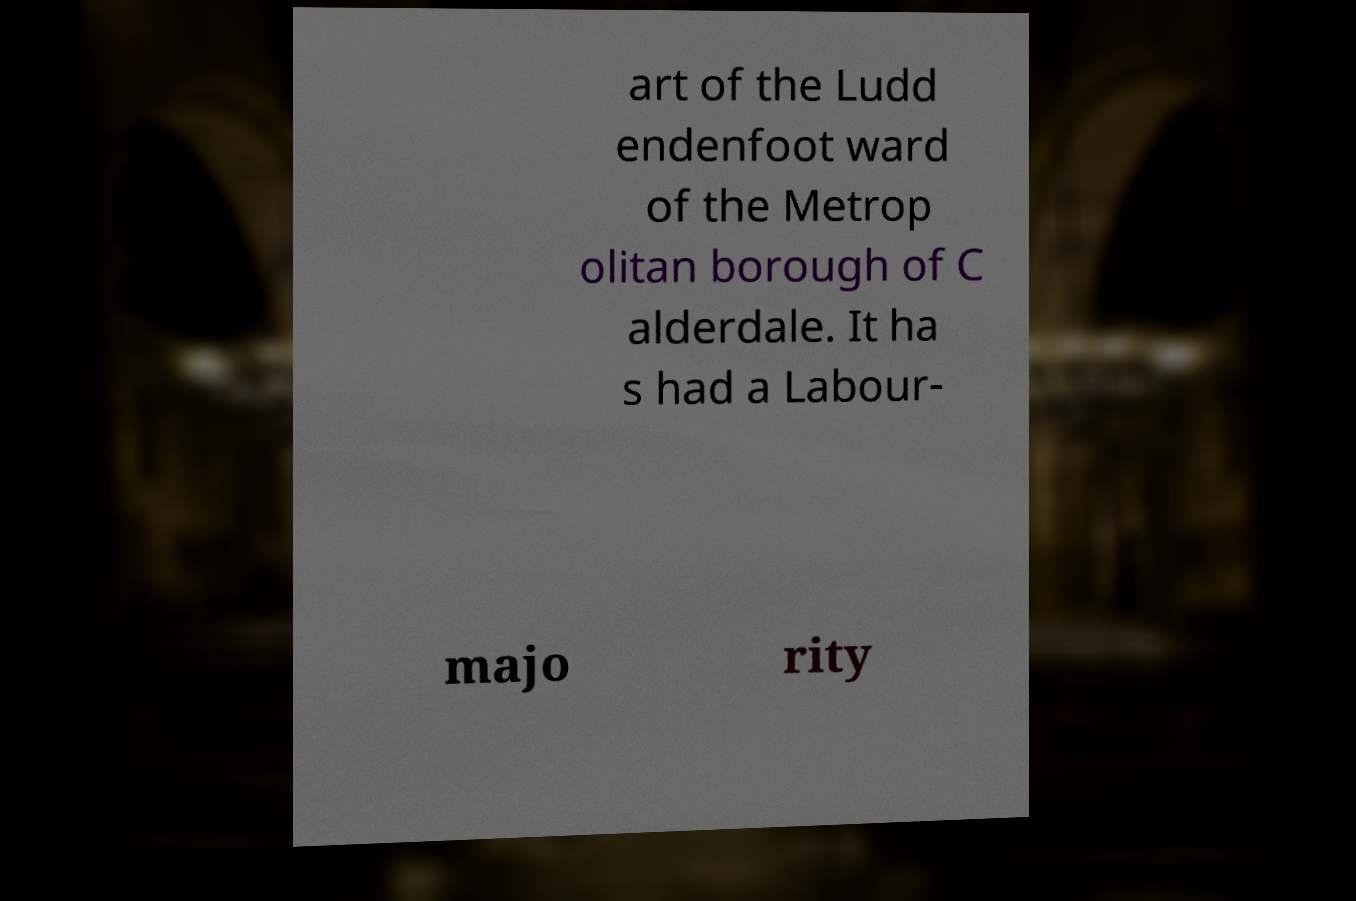Can you accurately transcribe the text from the provided image for me? art of the Ludd endenfoot ward of the Metrop olitan borough of C alderdale. It ha s had a Labour- majo rity 